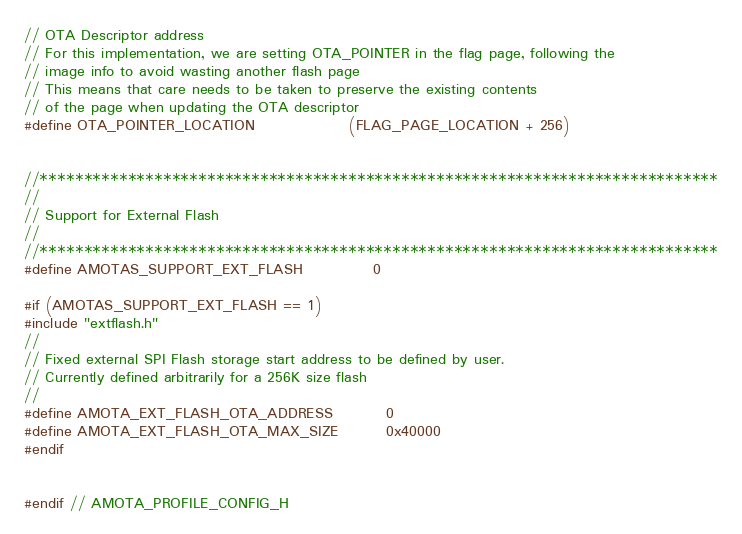Convert code to text. <code><loc_0><loc_0><loc_500><loc_500><_C_>

// OTA Descriptor address
// For this implementation, we are setting OTA_POINTER in the flag page, following the
// image info to avoid wasting another flash page
// This means that care needs to be taken to preserve the existing contents
// of the page when updating the OTA descriptor
#define OTA_POINTER_LOCATION                (FLAG_PAGE_LOCATION + 256)


//*****************************************************************************
//
// Support for External Flash
//
//*****************************************************************************
#define AMOTAS_SUPPORT_EXT_FLASH            0

#if (AMOTAS_SUPPORT_EXT_FLASH == 1)
#include "extflash.h"
//
// Fixed external SPI Flash storage start address to be defined by user.
// Currently defined arbitrarily for a 256K size flash
//
#define AMOTA_EXT_FLASH_OTA_ADDRESS         0
#define AMOTA_EXT_FLASH_OTA_MAX_SIZE        0x40000
#endif


#endif // AMOTA_PROFILE_CONFIG_H
</code> 